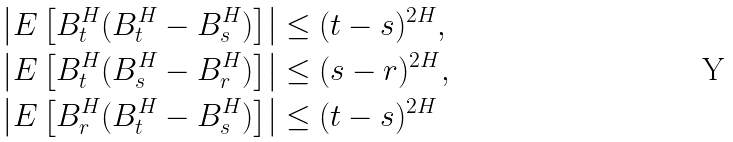Convert formula to latex. <formula><loc_0><loc_0><loc_500><loc_500>& \left | E \left [ B ^ { H } _ { t } ( B ^ { H } _ { t } - B ^ { H } _ { s } ) \right ] \right | \leq ( t - s ) ^ { 2 H } , \\ & \left | E \left [ B ^ { H } _ { t } ( B ^ { H } _ { s } - B ^ { H } _ { r } ) \right ] \right | \leq ( s - r ) ^ { 2 H } , \\ & \left | E \left [ B ^ { H } _ { r } ( B ^ { H } _ { t } - B ^ { H } _ { s } ) \right ] \right | \leq ( t - s ) ^ { 2 H }</formula> 